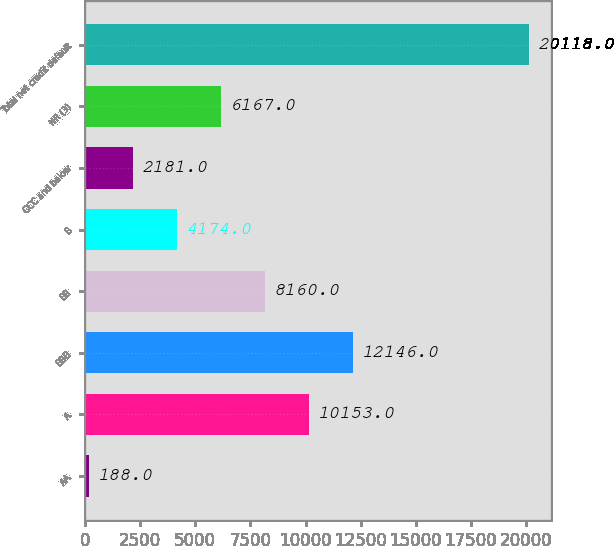Convert chart. <chart><loc_0><loc_0><loc_500><loc_500><bar_chart><fcel>AA<fcel>A<fcel>BBB<fcel>BB<fcel>B<fcel>CCC and below<fcel>NR (3)<fcel>Total net credit default<nl><fcel>188<fcel>10153<fcel>12146<fcel>8160<fcel>4174<fcel>2181<fcel>6167<fcel>20118<nl></chart> 